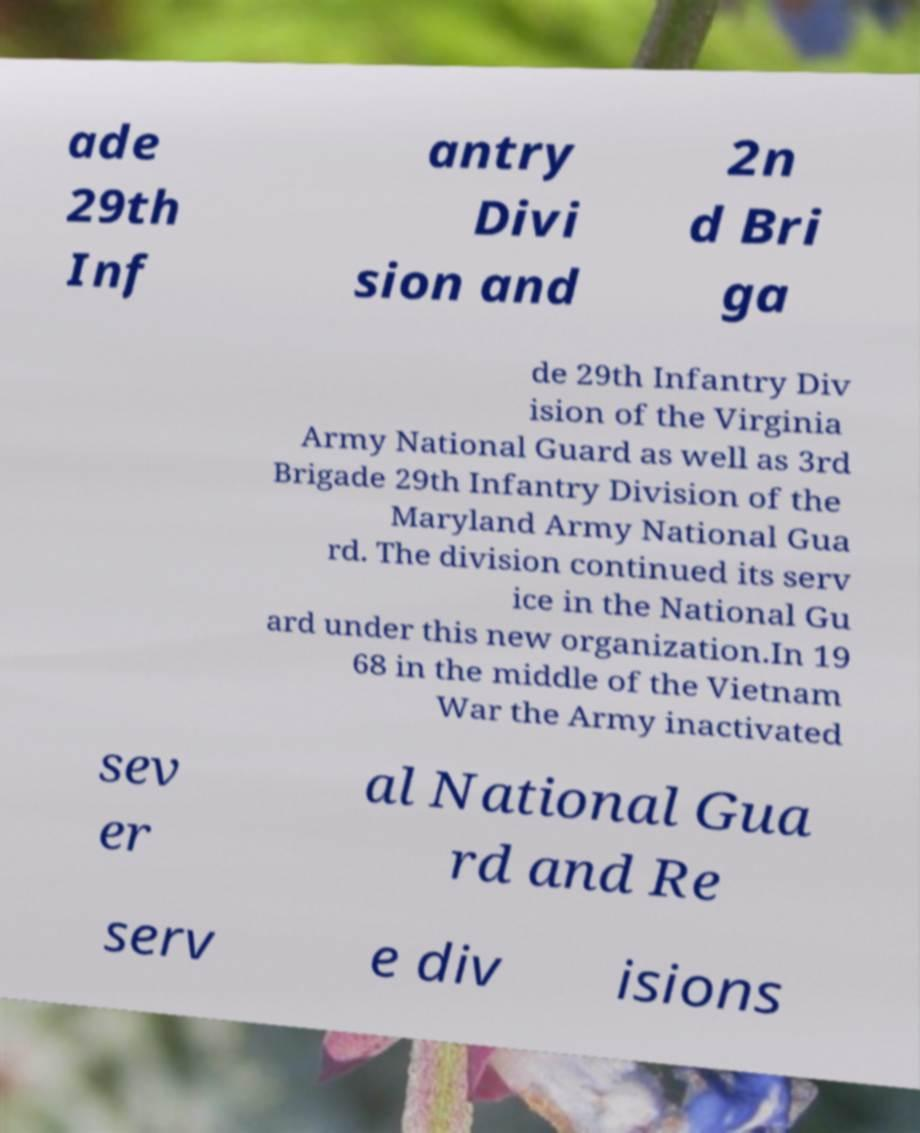Can you accurately transcribe the text from the provided image for me? ade 29th Inf antry Divi sion and 2n d Bri ga de 29th Infantry Div ision of the Virginia Army National Guard as well as 3rd Brigade 29th Infantry Division of the Maryland Army National Gua rd. The division continued its serv ice in the National Gu ard under this new organization.In 19 68 in the middle of the Vietnam War the Army inactivated sev er al National Gua rd and Re serv e div isions 